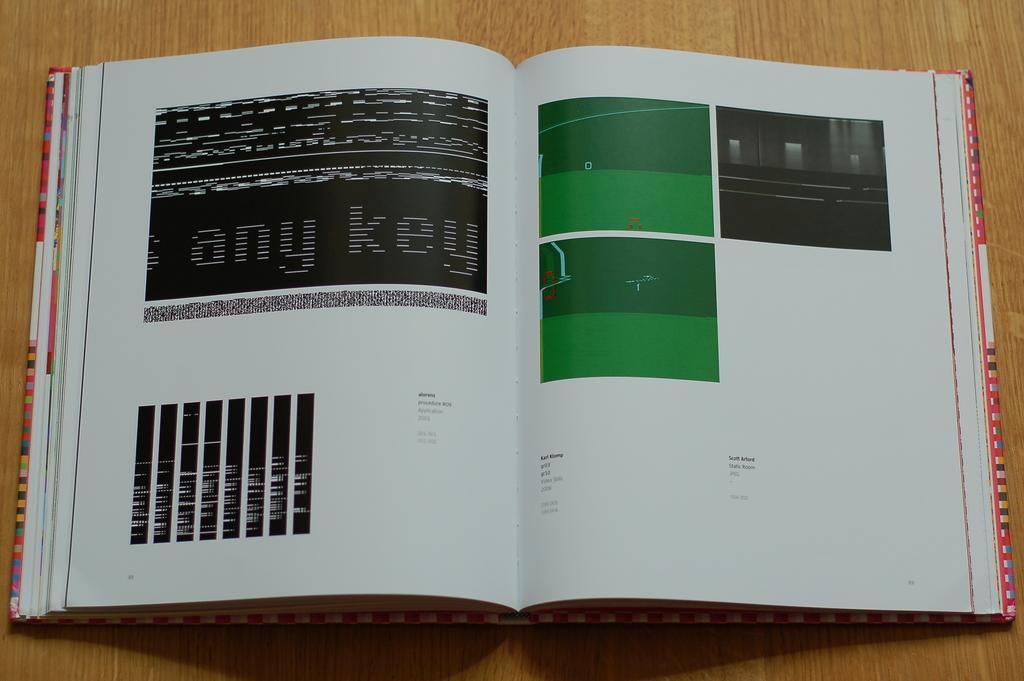What is the book trying to say?
Provide a succinct answer. Any key. What key can you press?
Keep it short and to the point. Any. 